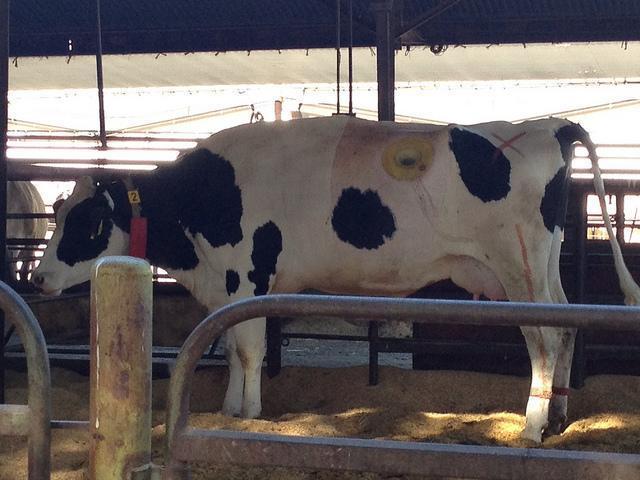How many umbrellas are visible?
Give a very brief answer. 0. 